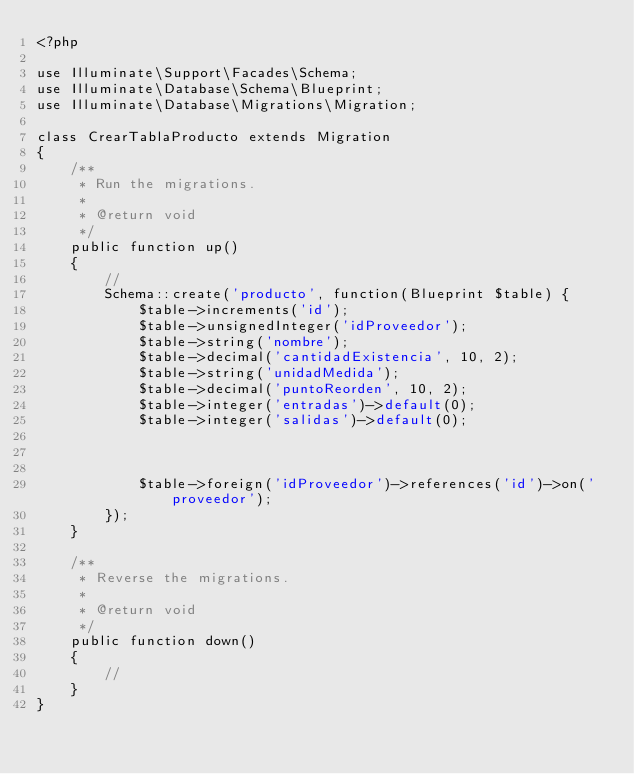<code> <loc_0><loc_0><loc_500><loc_500><_PHP_><?php

use Illuminate\Support\Facades\Schema;
use Illuminate\Database\Schema\Blueprint;
use Illuminate\Database\Migrations\Migration;

class CrearTablaProducto extends Migration
{
    /**
     * Run the migrations.
     *
     * @return void
     */
    public function up()
    {
        //
        Schema::create('producto', function(Blueprint $table) {
            $table->increments('id');
            $table->unsignedInteger('idProveedor');
            $table->string('nombre');
            $table->decimal('cantidadExistencia', 10, 2);
            $table->string('unidadMedida');
            $table->decimal('puntoReorden', 10, 2);
            $table->integer('entradas')->default(0);
            $table->integer('salidas')->default(0);

            

            $table->foreign('idProveedor')->references('id')->on('proveedor');
        });
    }

    /**
     * Reverse the migrations.
     *
     * @return void
     */
    public function down()
    {
        //
    }
}
</code> 